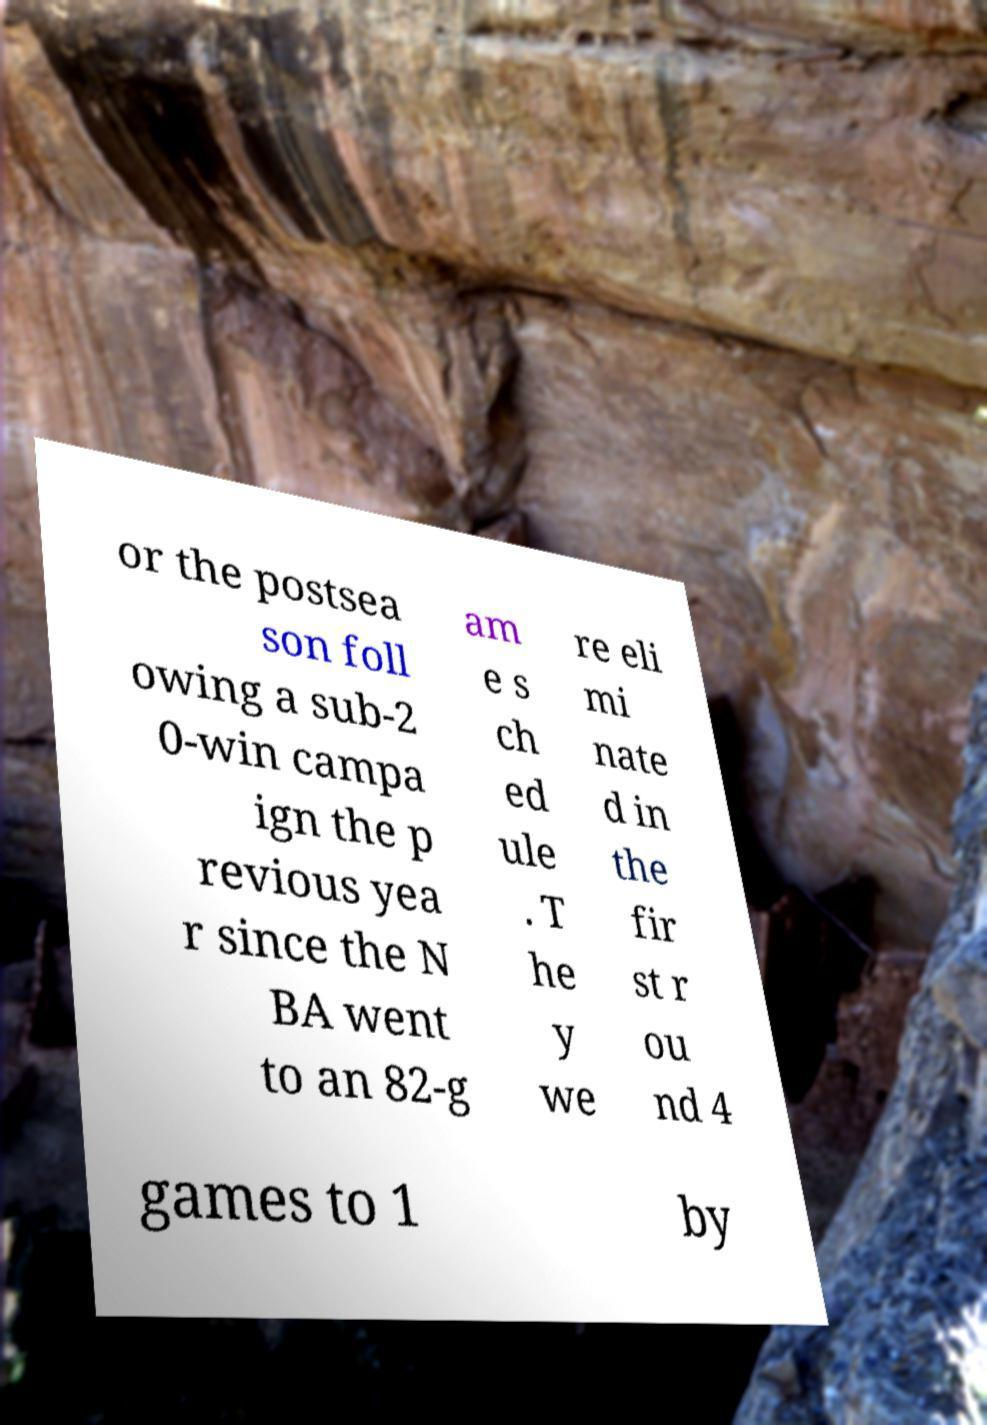Can you accurately transcribe the text from the provided image for me? or the postsea son foll owing a sub-2 0-win campa ign the p revious yea r since the N BA went to an 82-g am e s ch ed ule . T he y we re eli mi nate d in the fir st r ou nd 4 games to 1 by 